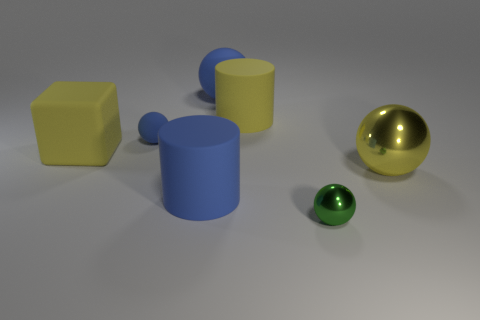What is the material of the sphere that is the same color as the block?
Provide a succinct answer. Metal. There is a large blue rubber object that is in front of the big cube; is it the same shape as the large yellow matte thing that is behind the large cube?
Give a very brief answer. Yes. What number of other things are there of the same color as the large metal thing?
Give a very brief answer. 2. What material is the tiny thing on the left side of the big blue matte thing that is left of the blue object that is to the right of the big blue cylinder made of?
Make the answer very short. Rubber. There is a yellow object behind the tiny ball behind the tiny metal ball; what is its material?
Your answer should be compact. Rubber. Is the number of big yellow metal things that are to the left of the large metallic object less than the number of purple shiny objects?
Your answer should be compact. No. What is the shape of the small blue matte thing to the right of the block?
Provide a short and direct response. Sphere. There is a green thing; is its size the same as the metal object behind the green metallic sphere?
Your answer should be compact. No. Is there a green sphere that has the same material as the large yellow cylinder?
Make the answer very short. No. What number of cubes are small shiny objects or big yellow matte things?
Offer a very short reply. 1. 